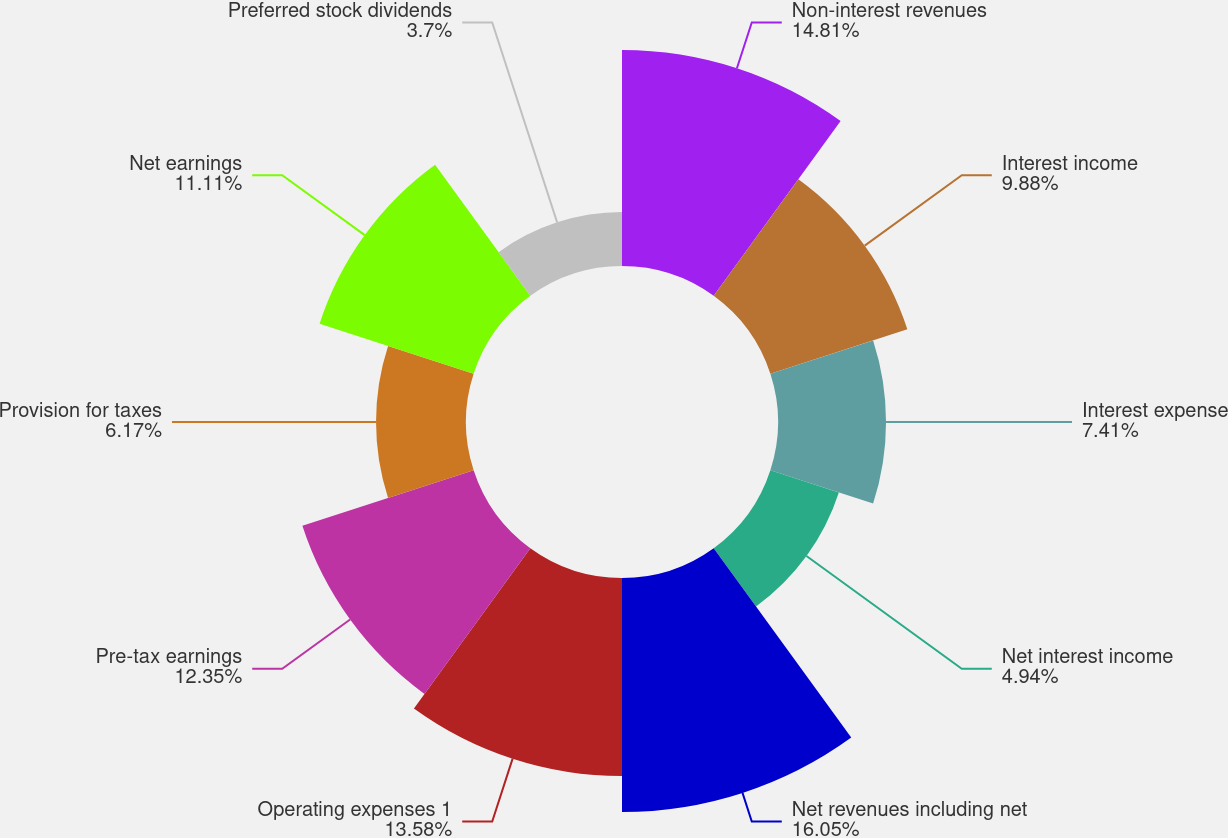<chart> <loc_0><loc_0><loc_500><loc_500><pie_chart><fcel>Non-interest revenues<fcel>Interest income<fcel>Interest expense<fcel>Net interest income<fcel>Net revenues including net<fcel>Operating expenses 1<fcel>Pre-tax earnings<fcel>Provision for taxes<fcel>Net earnings<fcel>Preferred stock dividends<nl><fcel>14.81%<fcel>9.88%<fcel>7.41%<fcel>4.94%<fcel>16.05%<fcel>13.58%<fcel>12.35%<fcel>6.17%<fcel>11.11%<fcel>3.7%<nl></chart> 